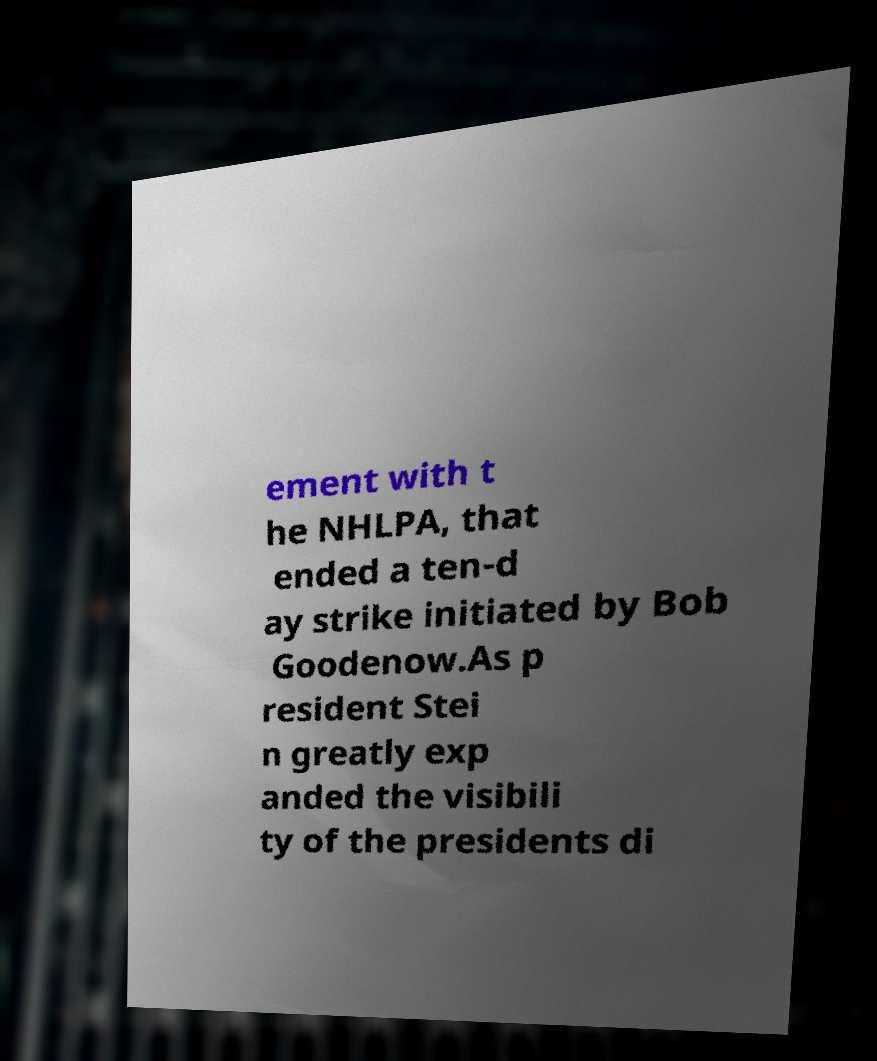Could you extract and type out the text from this image? ement with t he NHLPA, that ended a ten-d ay strike initiated by Bob Goodenow.As p resident Stei n greatly exp anded the visibili ty of the presidents di 